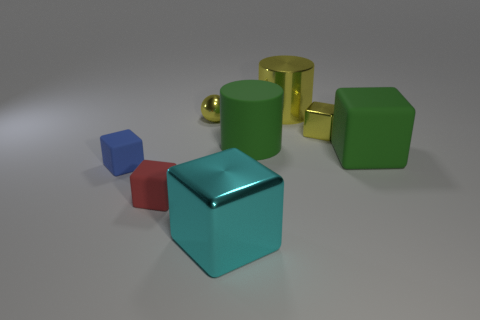Does this image resemble a real-life scenario? The image doesn't directly resemble a common real-life scenario as the objects are depicted with a simplistic, almost toy-like aesthetic. They may bring to mind educational materials used to teach children about shapes and colors, set against a nondescript background that suggests a controlled or artificial setting rather than a natural one. Could the arrangement of objects represent anything specific? While the arrangement doesn't seem to depict a specific scene or message, it may be interpreted in various ways. The objects could be seen as a collection of individual elements that stand out for their unique shapes and colors, inviting viewers to compare and contrast their forms. The placement appears arbitrary, hinting at no clear relationship between the objects. 